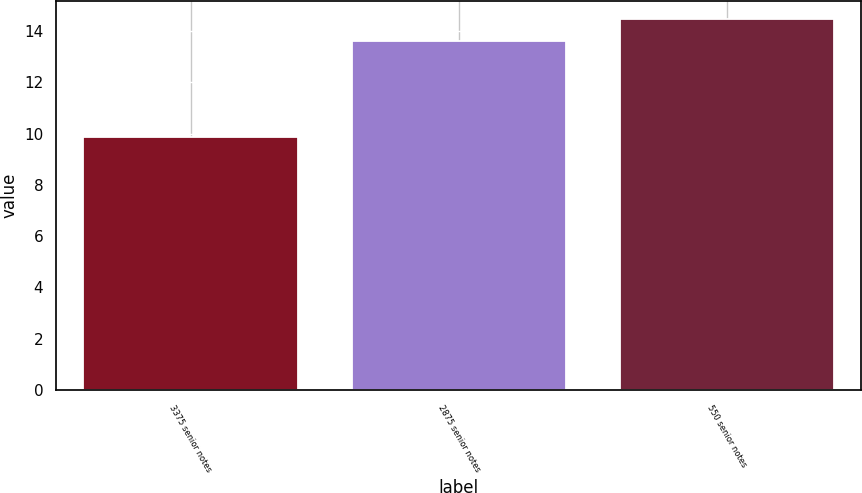<chart> <loc_0><loc_0><loc_500><loc_500><bar_chart><fcel>3375 senior notes<fcel>2875 senior notes<fcel>550 senior notes<nl><fcel>9.86<fcel>13.62<fcel>14.46<nl></chart> 